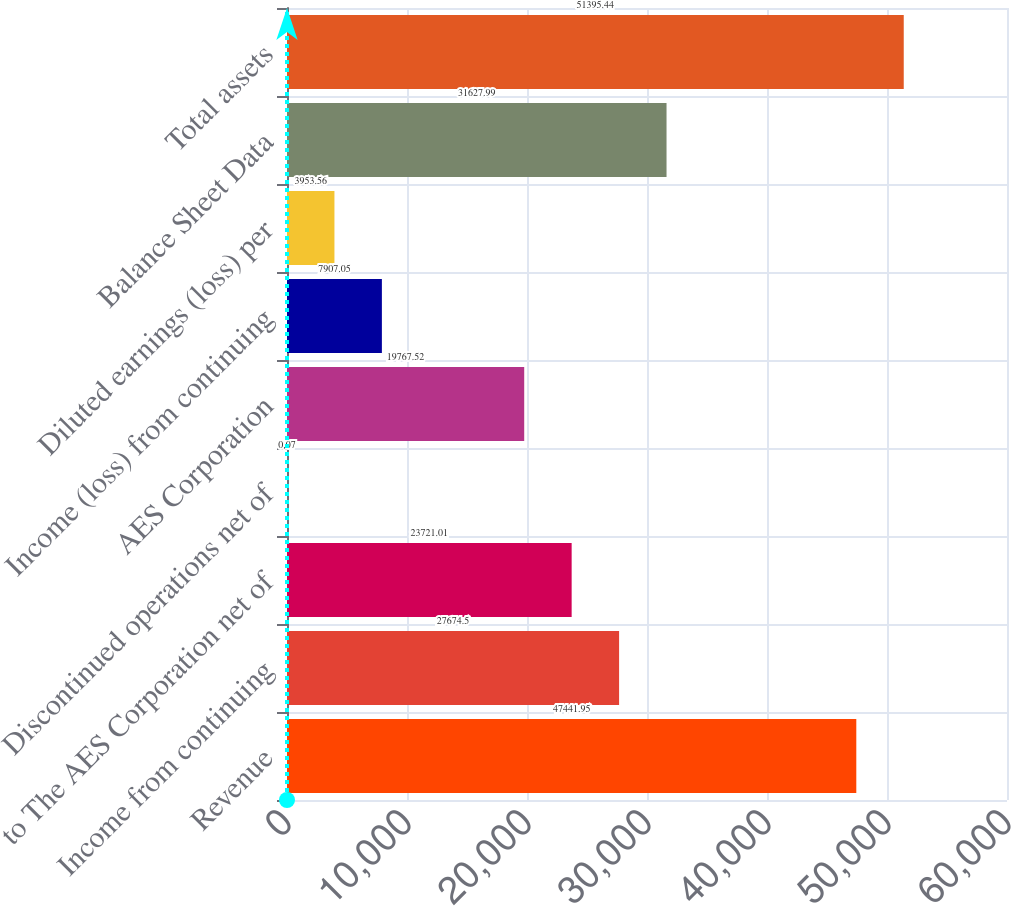Convert chart to OTSL. <chart><loc_0><loc_0><loc_500><loc_500><bar_chart><fcel>Revenue<fcel>Income from continuing<fcel>to The AES Corporation net of<fcel>Discontinued operations net of<fcel>AES Corporation<fcel>Income (loss) from continuing<fcel>Diluted earnings (loss) per<fcel>Balance Sheet Data<fcel>Total assets<nl><fcel>47441.9<fcel>27674.5<fcel>23721<fcel>0.07<fcel>19767.5<fcel>7907.05<fcel>3953.56<fcel>31628<fcel>51395.4<nl></chart> 